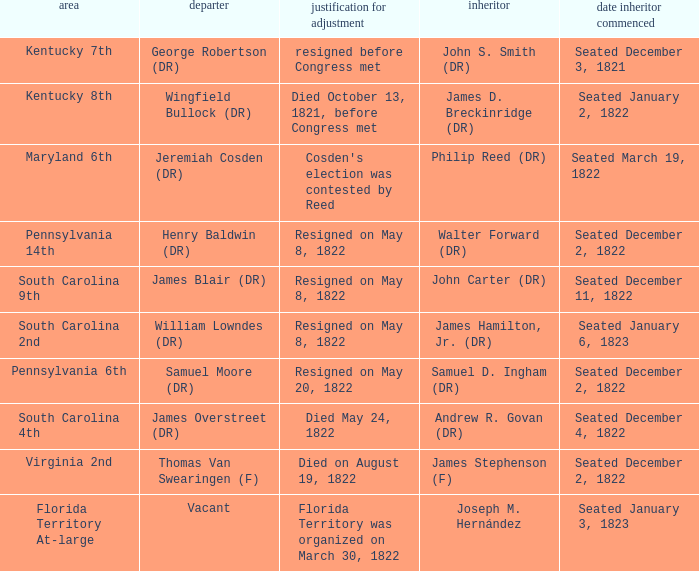Who is the vacator when south carolina 4th is the district? James Overstreet (DR). 